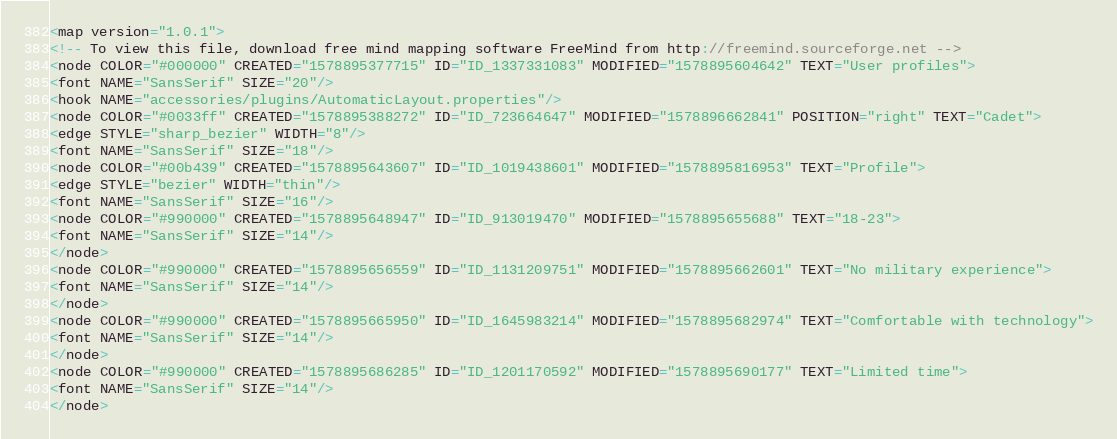<code> <loc_0><loc_0><loc_500><loc_500><_ObjectiveC_><map version="1.0.1">
<!-- To view this file, download free mind mapping software FreeMind from http://freemind.sourceforge.net -->
<node COLOR="#000000" CREATED="1578895377715" ID="ID_1337331083" MODIFIED="1578895604642" TEXT="User profiles">
<font NAME="SansSerif" SIZE="20"/>
<hook NAME="accessories/plugins/AutomaticLayout.properties"/>
<node COLOR="#0033ff" CREATED="1578895388272" ID="ID_723664647" MODIFIED="1578896662841" POSITION="right" TEXT="Cadet">
<edge STYLE="sharp_bezier" WIDTH="8"/>
<font NAME="SansSerif" SIZE="18"/>
<node COLOR="#00b439" CREATED="1578895643607" ID="ID_1019438601" MODIFIED="1578895816953" TEXT="Profile">
<edge STYLE="bezier" WIDTH="thin"/>
<font NAME="SansSerif" SIZE="16"/>
<node COLOR="#990000" CREATED="1578895648947" ID="ID_913019470" MODIFIED="1578895655688" TEXT="18-23">
<font NAME="SansSerif" SIZE="14"/>
</node>
<node COLOR="#990000" CREATED="1578895656559" ID="ID_1131209751" MODIFIED="1578895662601" TEXT="No military experience">
<font NAME="SansSerif" SIZE="14"/>
</node>
<node COLOR="#990000" CREATED="1578895665950" ID="ID_1645983214" MODIFIED="1578895682974" TEXT="Comfortable with technology">
<font NAME="SansSerif" SIZE="14"/>
</node>
<node COLOR="#990000" CREATED="1578895686285" ID="ID_1201170592" MODIFIED="1578895690177" TEXT="Limited time">
<font NAME="SansSerif" SIZE="14"/>
</node></code> 